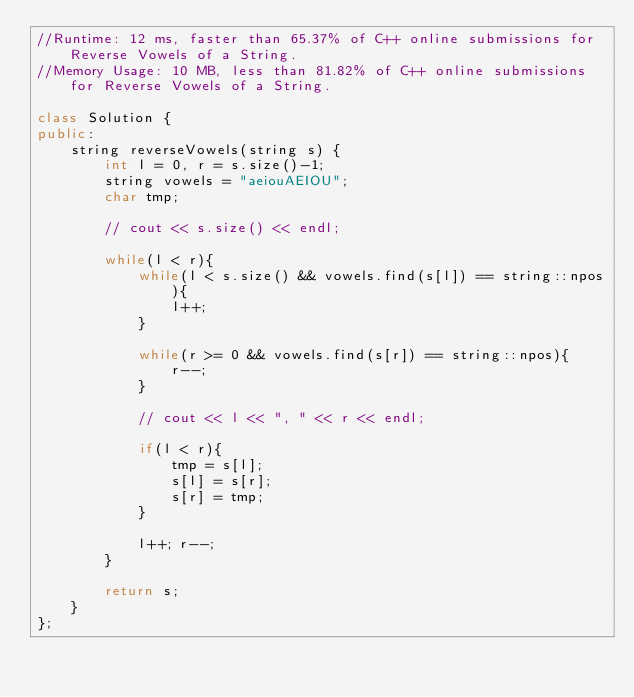<code> <loc_0><loc_0><loc_500><loc_500><_C++_>//Runtime: 12 ms, faster than 65.37% of C++ online submissions for Reverse Vowels of a String.
//Memory Usage: 10 MB, less than 81.82% of C++ online submissions for Reverse Vowels of a String.

class Solution {
public:
    string reverseVowels(string s) {
        int l = 0, r = s.size()-1;
        string vowels = "aeiouAEIOU";
        char tmp;
        
        // cout << s.size() << endl;
        
        while(l < r){
            while(l < s.size() && vowels.find(s[l]) == string::npos){
                l++;
            }
            
            while(r >= 0 && vowels.find(s[r]) == string::npos){
                r--;
            }
            
            // cout << l << ", " << r << endl;
            
            if(l < r){
                tmp = s[l];
                s[l] = s[r];
                s[r] = tmp;
            }
            
            l++; r--;
        }
        
        return s;
    }
};
</code> 